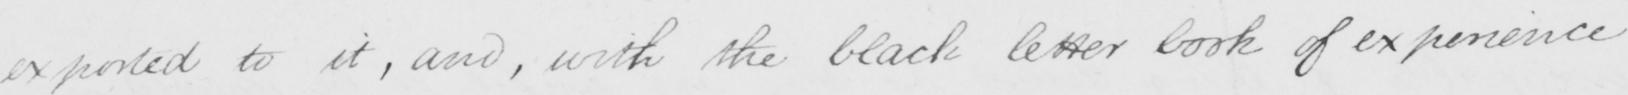Can you tell me what this handwritten text says? exported to it , and , with the black letter book of experience 